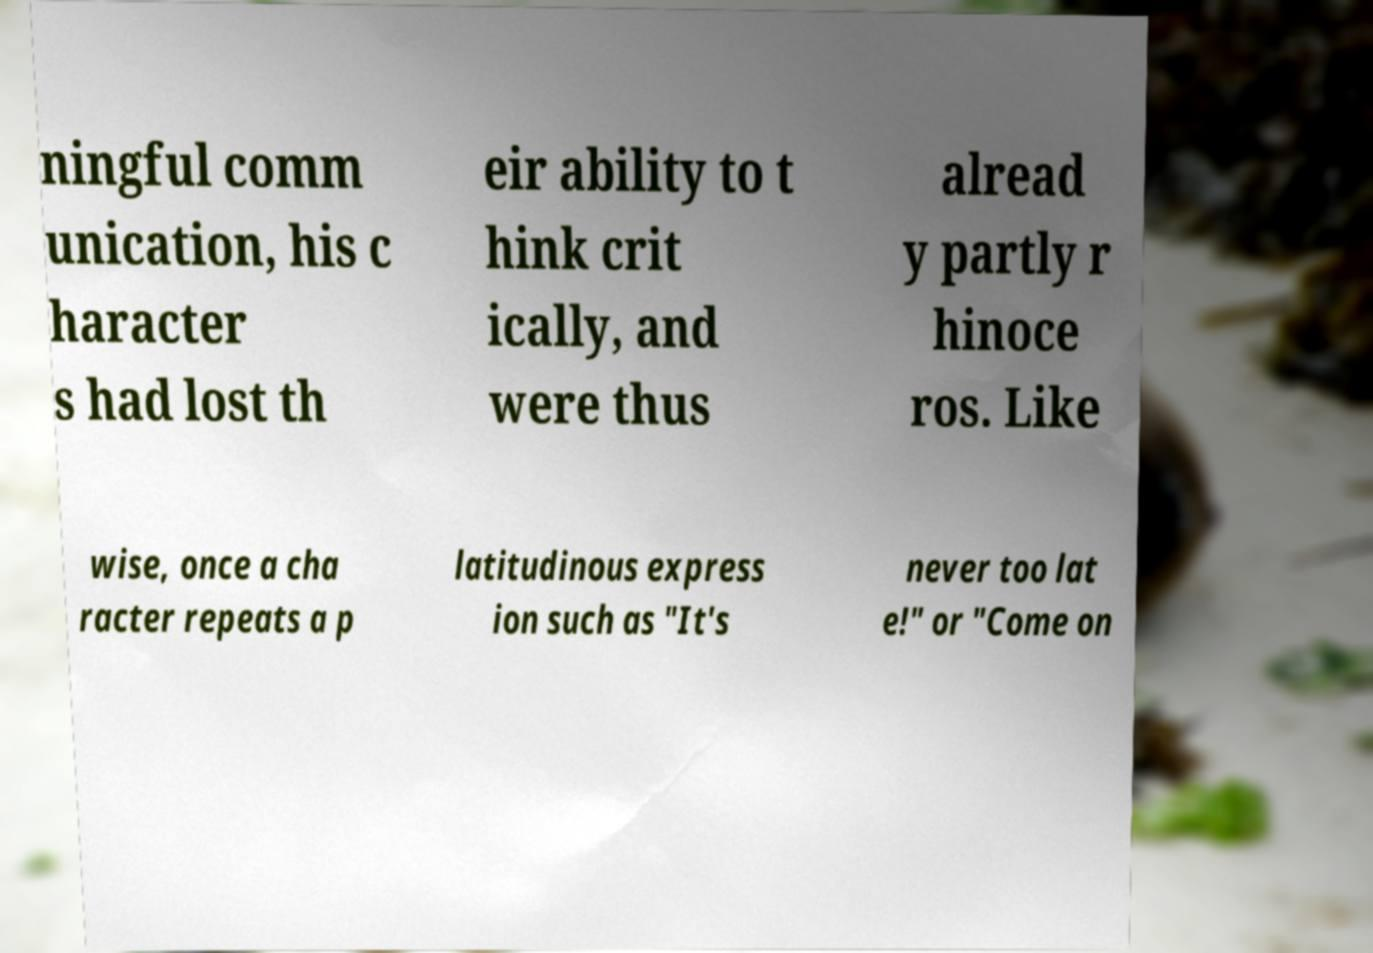For documentation purposes, I need the text within this image transcribed. Could you provide that? ningful comm unication, his c haracter s had lost th eir ability to t hink crit ically, and were thus alread y partly r hinoce ros. Like wise, once a cha racter repeats a p latitudinous express ion such as "It's never too lat e!" or "Come on 